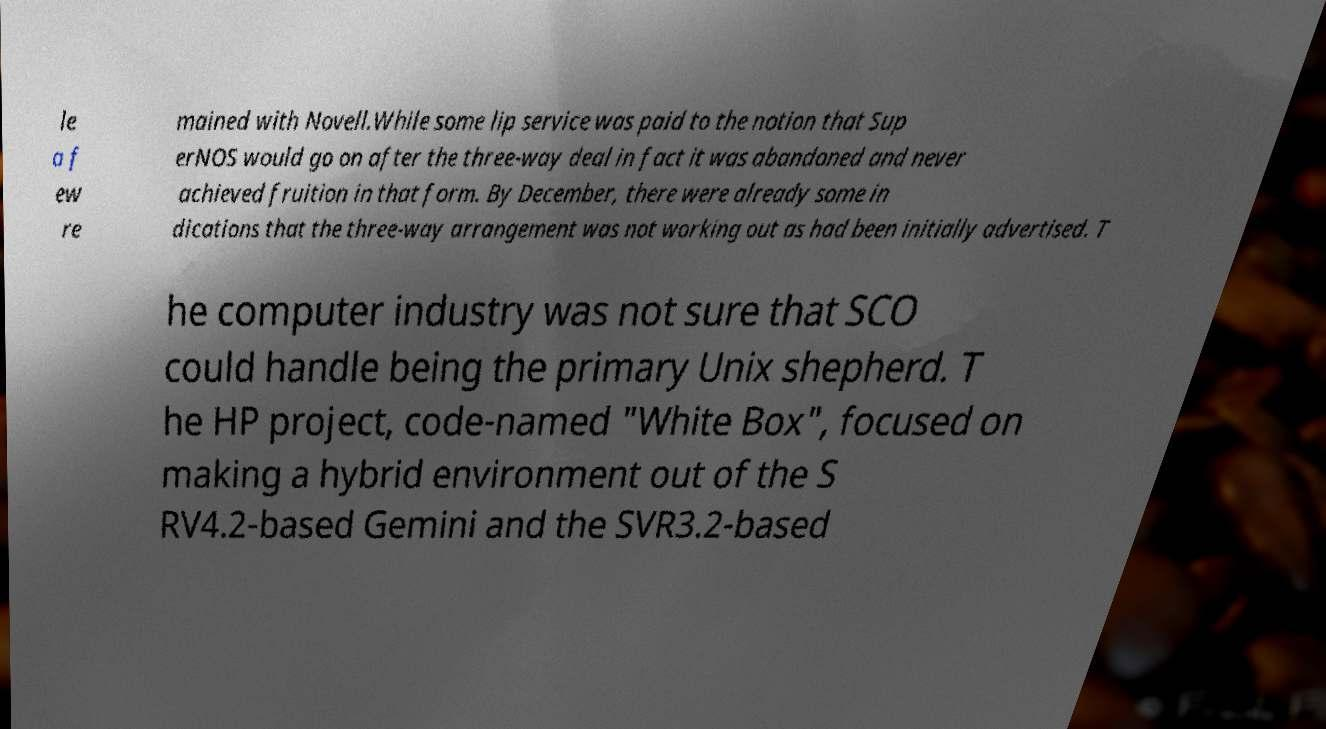Can you accurately transcribe the text from the provided image for me? le a f ew re mained with Novell.While some lip service was paid to the notion that Sup erNOS would go on after the three-way deal in fact it was abandoned and never achieved fruition in that form. By December, there were already some in dications that the three-way arrangement was not working out as had been initially advertised. T he computer industry was not sure that SCO could handle being the primary Unix shepherd. T he HP project, code-named "White Box", focused on making a hybrid environment out of the S RV4.2-based Gemini and the SVR3.2-based 